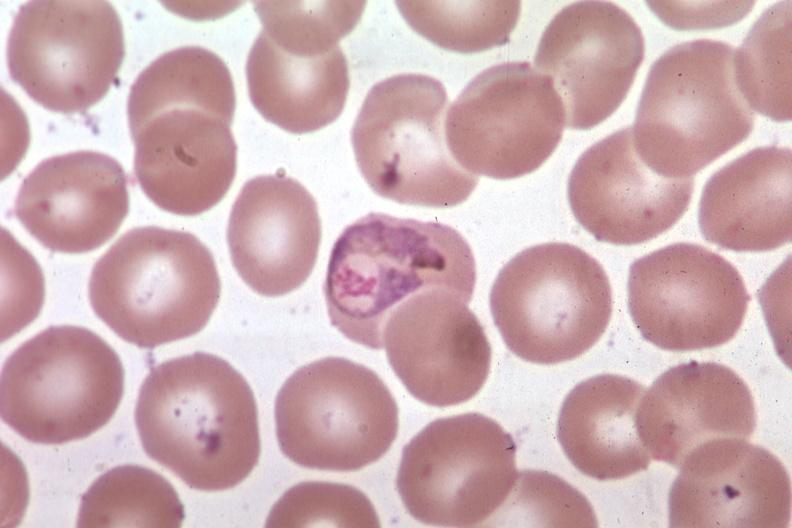s stillborn macerated present?
Answer the question using a single word or phrase. No 